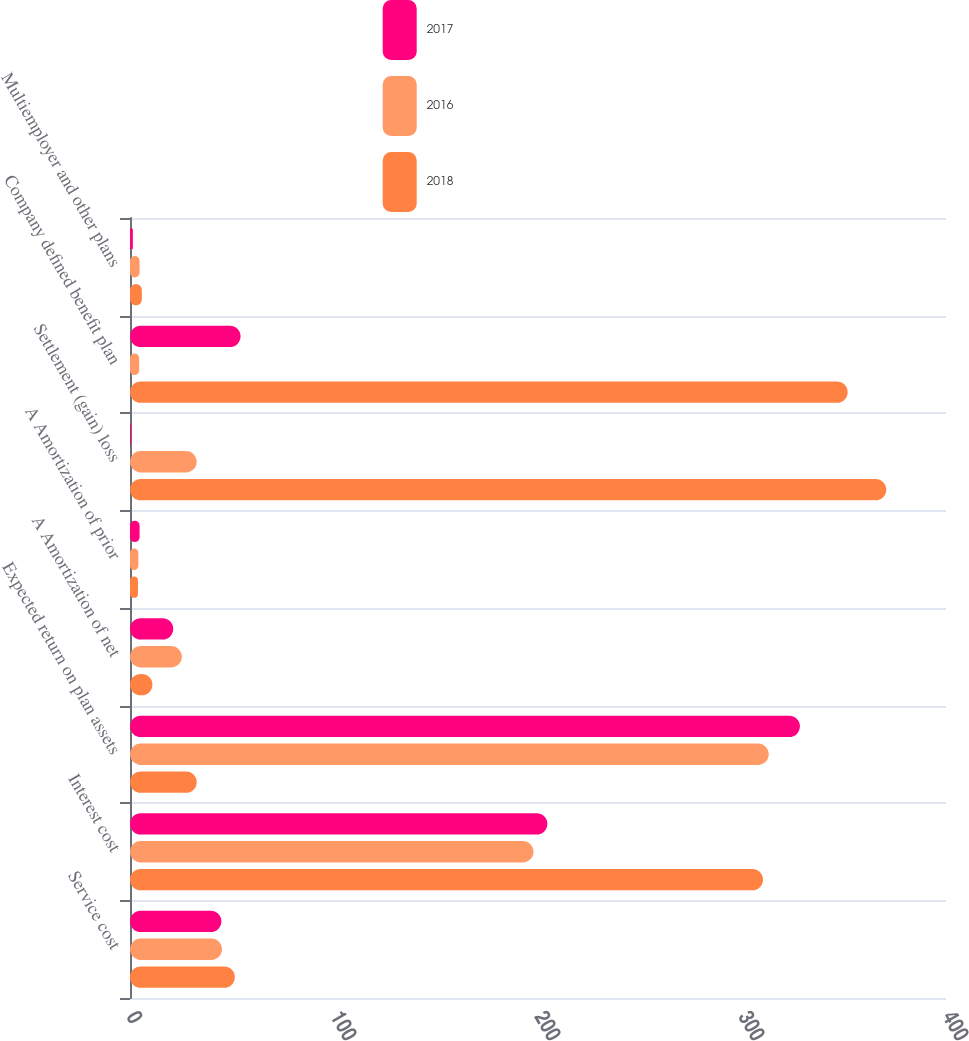<chart> <loc_0><loc_0><loc_500><loc_500><stacked_bar_chart><ecel><fcel>Service cost<fcel>Interest cost<fcel>Expected return on plan assets<fcel>A Amortization of net<fcel>A Amortization of prior<fcel>Settlement (gain) loss<fcel>Company defined benefit plan<fcel>Multiemployer and other plans<nl><fcel>2017<fcel>44.8<fcel>204.6<fcel>328.4<fcel>21.2<fcel>4.7<fcel>0.5<fcel>54.2<fcel>1.4<nl><fcel>2016<fcel>45.1<fcel>197.8<fcel>313.1<fcel>25.4<fcel>4.1<fcel>32.7<fcel>4.5<fcel>4.7<nl><fcel>2018<fcel>51.4<fcel>310.3<fcel>32.7<fcel>11<fcel>3.9<fcel>370.7<fcel>351.8<fcel>5.8<nl></chart> 